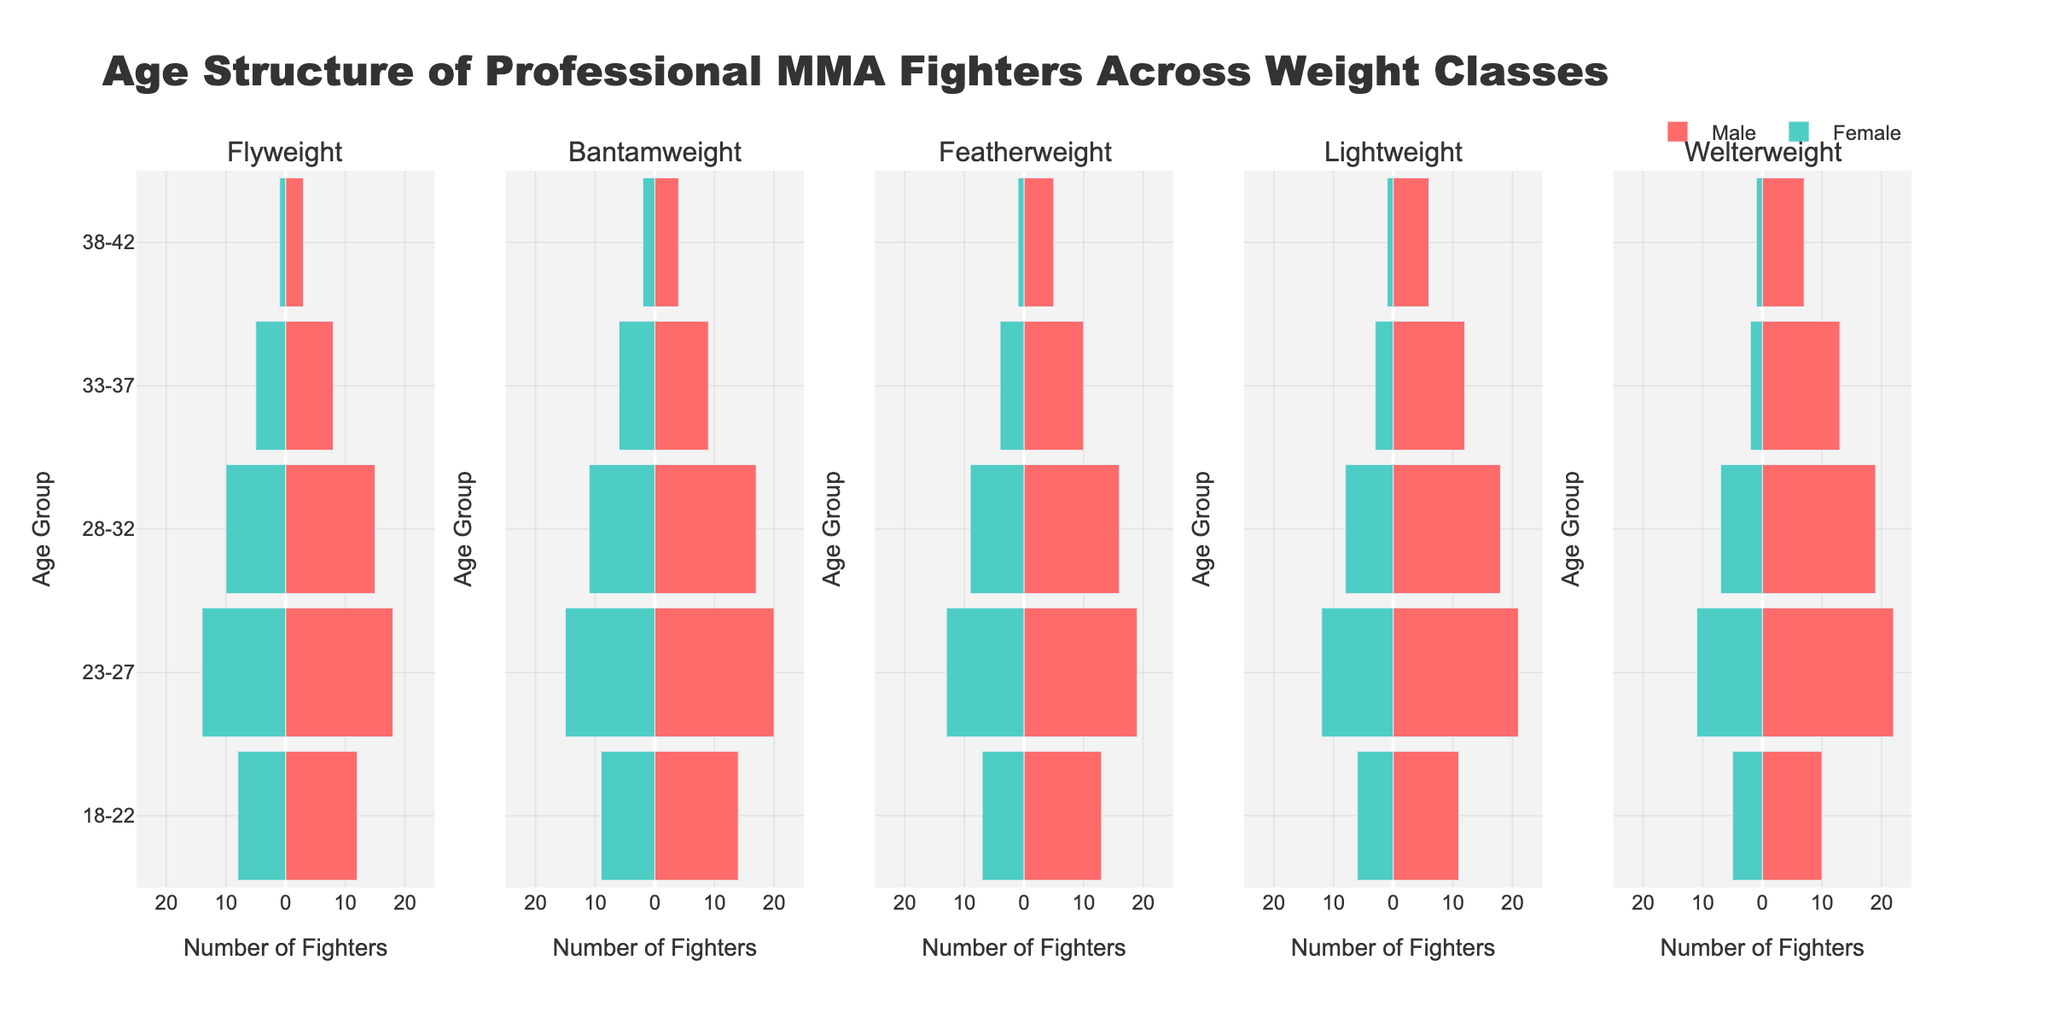Which weight class has the most male fighters in the 23-27 age group? By observing the height of the male bars in the 23-27 age group across different weight classes, we see that Lightweight has the tallest bar, indicating the most male fighters in that age group.
Answer: Lightweight How many female fighters are in the 28-32 age group for Bantamweight? Look at the length of the negative (left-side) bar in the Bantamweight column for the 28-32 age group, which represents female fighters. The length indicates 11 female fighters.
Answer: 11 Compare the number of male and female fighters in the Flyweight 33-37 age group. Who has more? In the Flyweight column for the 33-37 age group, the male bar is 8 units tall, and the female bar (left side) is 5 units long. Therefore, there are more male fighters.
Answer: Males What is the total number of fighters in the 18-22 age group for Welterweight? Add the number of male and female fighters in the Welterweight column for the 18-22 age group. Males are 10 and females are 5, so 10 + 5 = 15.
Answer: 15 Which weight class has the highest number of female fighters overall? Sum the female fighters (left-side bars) for each weight class. Flyweight: 8+14+10+5+1 = 38, Bantamweight: 9+15+11+6+2=43, Featherweight: 7+13+9+4+1=34, Lightweight: 6+12+8+3+1=30, Welterweight: 5+11+7+2+1=26. Bantamweight has the highest number at 43.
Answer: Bantamweight Which age group in the Featherweight class has the smallest number of female fighters? Look at the negative bars (left-side) in the Featherweight column and find the shortest one. The 38-42 age group has the smallest number of female fighters, represented by 1.
Answer: 38-42 Are there more female fighters in the Flyweight 23-27 age group or the Featherweight 23-27 age group? Compare the length of the negative bars (left-side) in the Flyweight and Featherweight columns for the 23-27 age group. Flyweight has 14, and Featherweight has 13 female fighters, so Flyweight has more.
Answer: Flyweight How does the number of male fighters in the Lightweight 28-32 age group compare to the Flyweight 28-32 age group? Compare the height of the male bars in the 28-32 age group for both weight classes. Lightweight has a bar height of 18, while Flyweight has a bar height of 15, so Lightweight has more.
Answer: Lightweight What is the total number of fighters across all weight classes in the 38-42 age group? Sum the number of male and female fighters in the 38-42 age group across all weight classes: Flyweight: 3+1, Bantamweight: 4+2, Featherweight: 5+1, Lightweight: 6+1, Welterweight: 7+1. Total is 3+1+4+2+5+1+6+1+7+1 = 31.
Answer: 31 